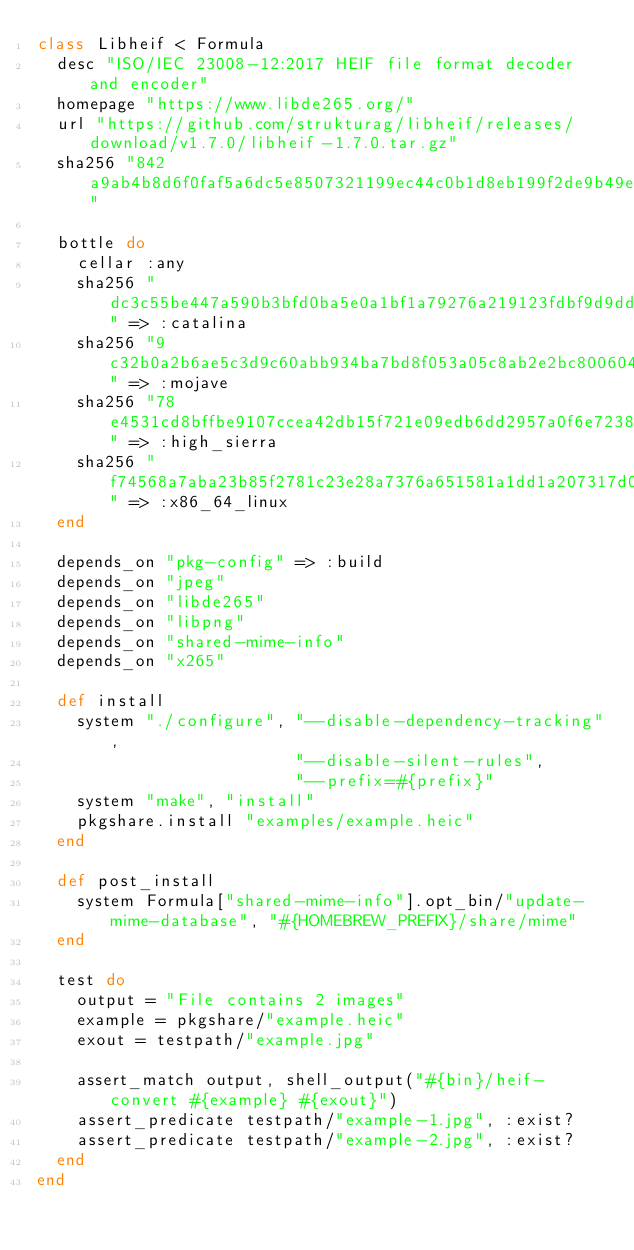Convert code to text. <code><loc_0><loc_0><loc_500><loc_500><_Ruby_>class Libheif < Formula
  desc "ISO/IEC 23008-12:2017 HEIF file format decoder and encoder"
  homepage "https://www.libde265.org/"
  url "https://github.com/strukturag/libheif/releases/download/v1.7.0/libheif-1.7.0.tar.gz"
  sha256 "842a9ab4b8d6f0faf5a6dc5e8507321199ec44c0b1d8eb199f2de9b49e2db092"

  bottle do
    cellar :any
    sha256 "dc3c55be447a590b3bfd0ba5e0a1bf1a79276a219123fdbf9d9dda5995a95de0" => :catalina
    sha256 "9c32b0a2b6ae5c3d9c60abb934ba7bd8f053a05c8ab2e2bc800604dee7ae227b" => :mojave
    sha256 "78e4531cd8bffbe9107ccea42db15f721e09edb6dd2957a0f6e723824415c456" => :high_sierra
    sha256 "f74568a7aba23b85f2781c23e28a7376a651581a1dd1a207317d0edc359bc59e" => :x86_64_linux
  end

  depends_on "pkg-config" => :build
  depends_on "jpeg"
  depends_on "libde265"
  depends_on "libpng"
  depends_on "shared-mime-info"
  depends_on "x265"

  def install
    system "./configure", "--disable-dependency-tracking",
                          "--disable-silent-rules",
                          "--prefix=#{prefix}"
    system "make", "install"
    pkgshare.install "examples/example.heic"
  end

  def post_install
    system Formula["shared-mime-info"].opt_bin/"update-mime-database", "#{HOMEBREW_PREFIX}/share/mime"
  end

  test do
    output = "File contains 2 images"
    example = pkgshare/"example.heic"
    exout = testpath/"example.jpg"

    assert_match output, shell_output("#{bin}/heif-convert #{example} #{exout}")
    assert_predicate testpath/"example-1.jpg", :exist?
    assert_predicate testpath/"example-2.jpg", :exist?
  end
end
</code> 